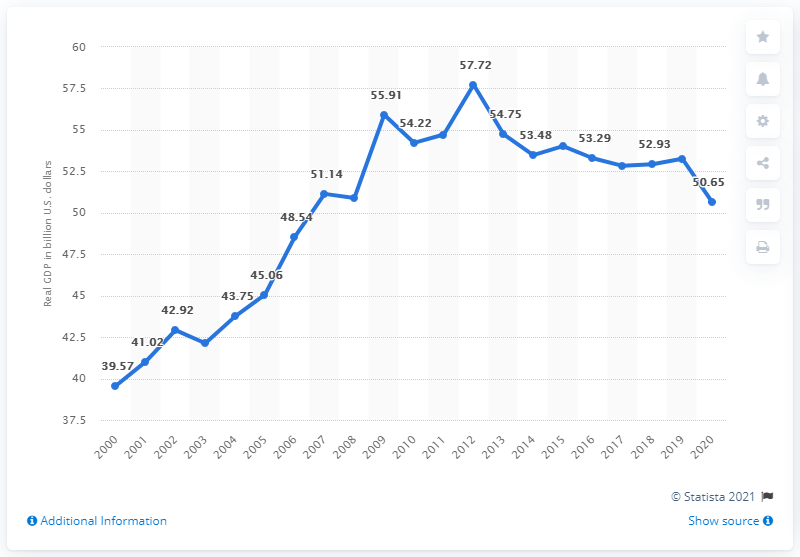Identify some key points in this picture. In the previous year, the Gross Domestic Product (GDP) of Alaska was 53.26 billion dollars. In 2020, Alaska's Gross Domestic Product (GDP) was 50.65. 